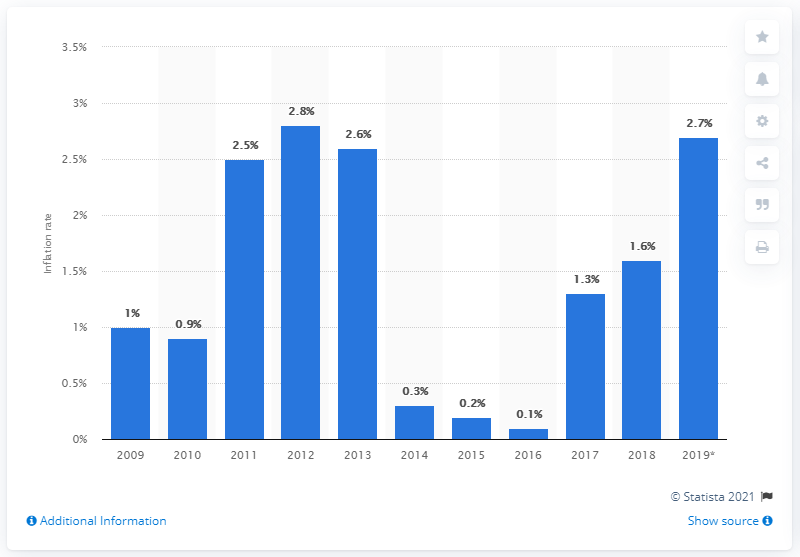List a handful of essential elements in this visual. The harmonized inflation rate in the Netherlands increased by 1.3% in 2019. 